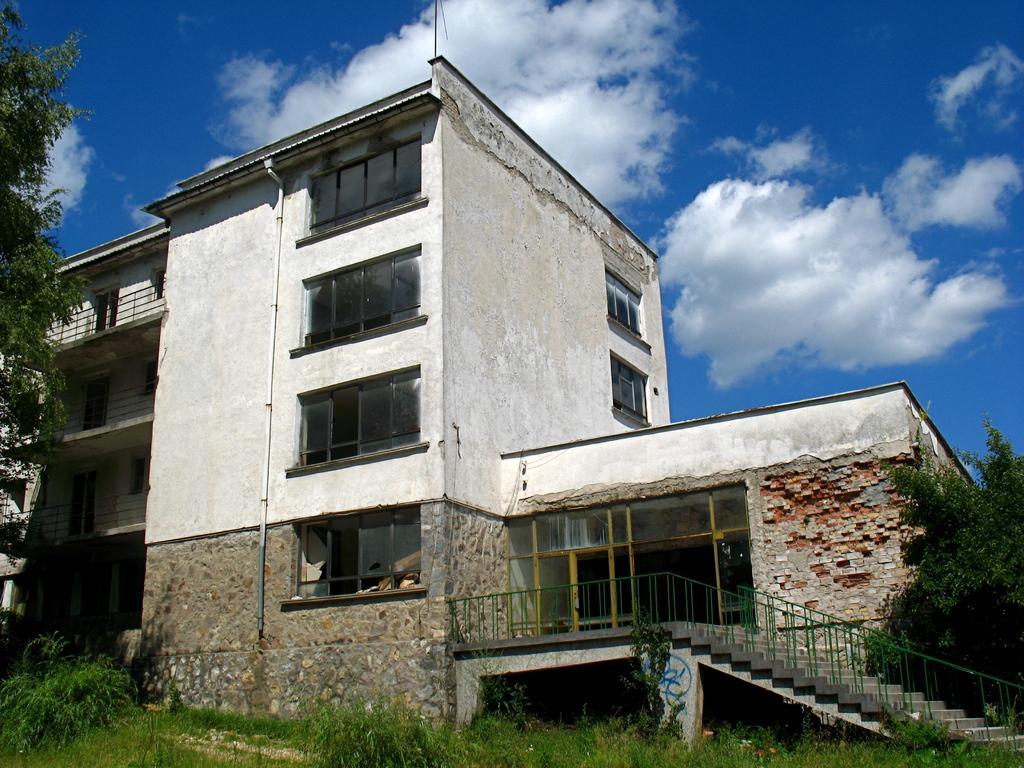Please provide a concise description of this image. At the bottom of the picture, we see the grass. On the right side, we see a tree, staircase and stair railing. On the left side, we see a tree. In the background, we see a building in white color. It has windows. At the top of the picture, we see the clouds and the sky, which is blue in color. 